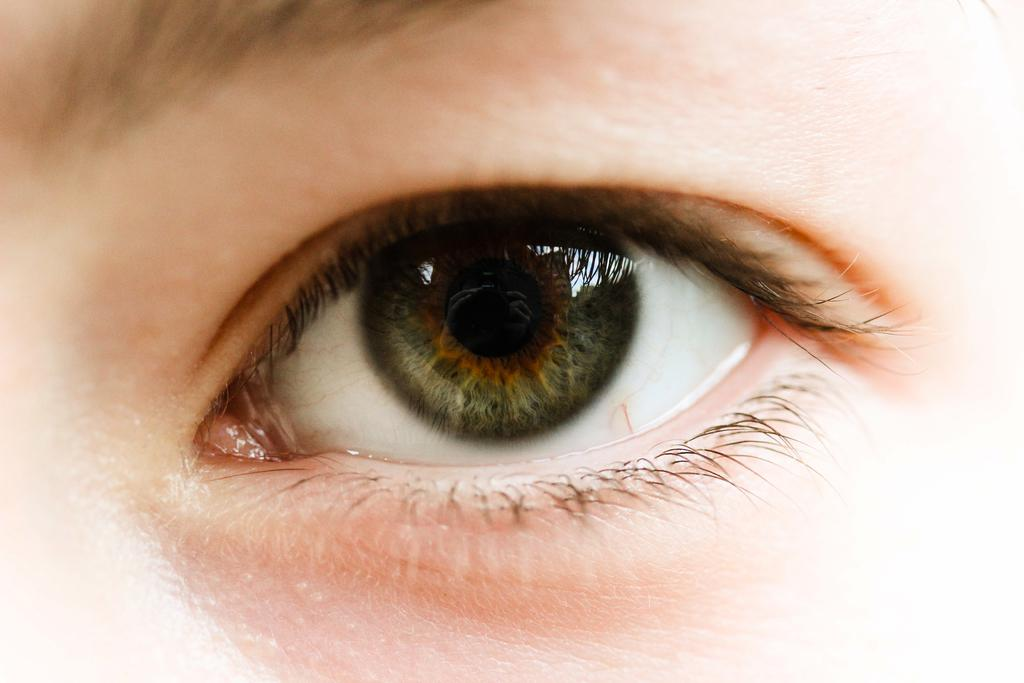What is the main subject of the image? The main subject of the image is a human eye. What type of curtain is hanging in the background of the image? There is no curtain present in the image; it features a human eye. How many eggs can be seen in the image? There are no eggs present in the image; it features a human eye. 